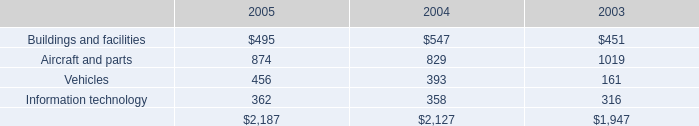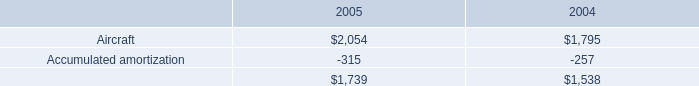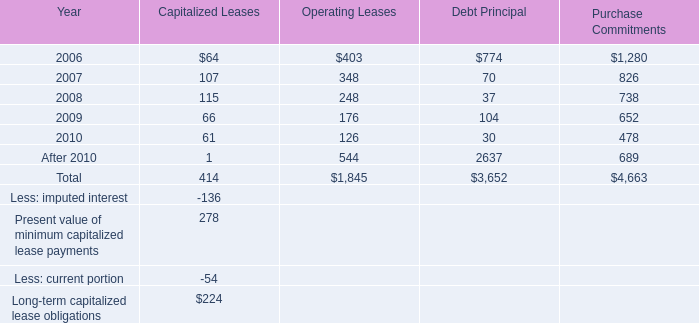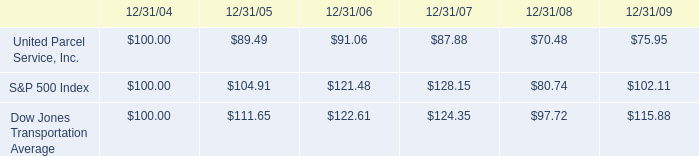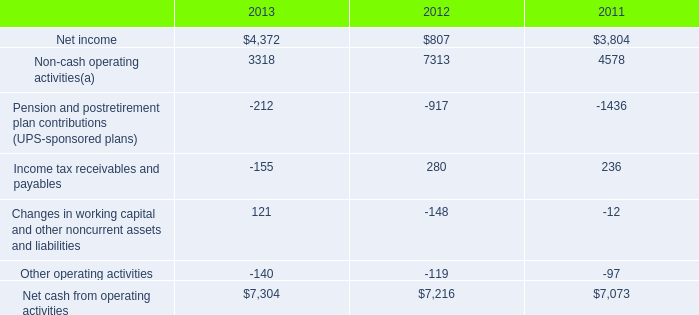what was the percentage change in net cash from operating activities from 2012 to 2013? 
Computations: ((7304 - 7216) / 7216)
Answer: 0.0122. 